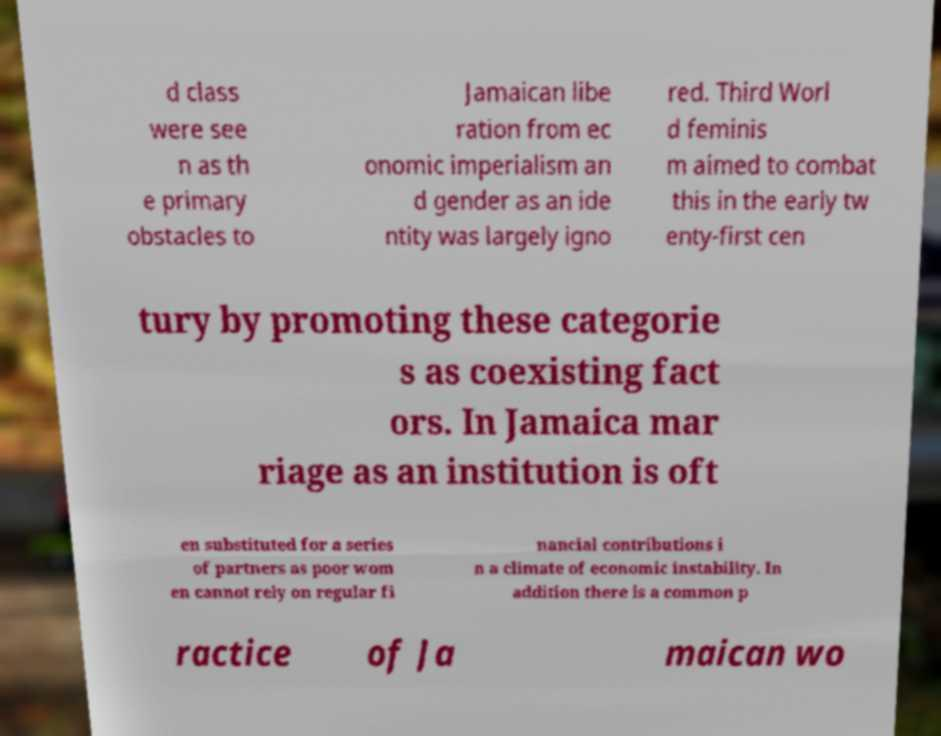Can you read and provide the text displayed in the image?This photo seems to have some interesting text. Can you extract and type it out for me? d class were see n as th e primary obstacles to Jamaican libe ration from ec onomic imperialism an d gender as an ide ntity was largely igno red. Third Worl d feminis m aimed to combat this in the early tw enty-first cen tury by promoting these categorie s as coexisting fact ors. In Jamaica mar riage as an institution is oft en substituted for a series of partners as poor wom en cannot rely on regular fi nancial contributions i n a climate of economic instability. In addition there is a common p ractice of Ja maican wo 